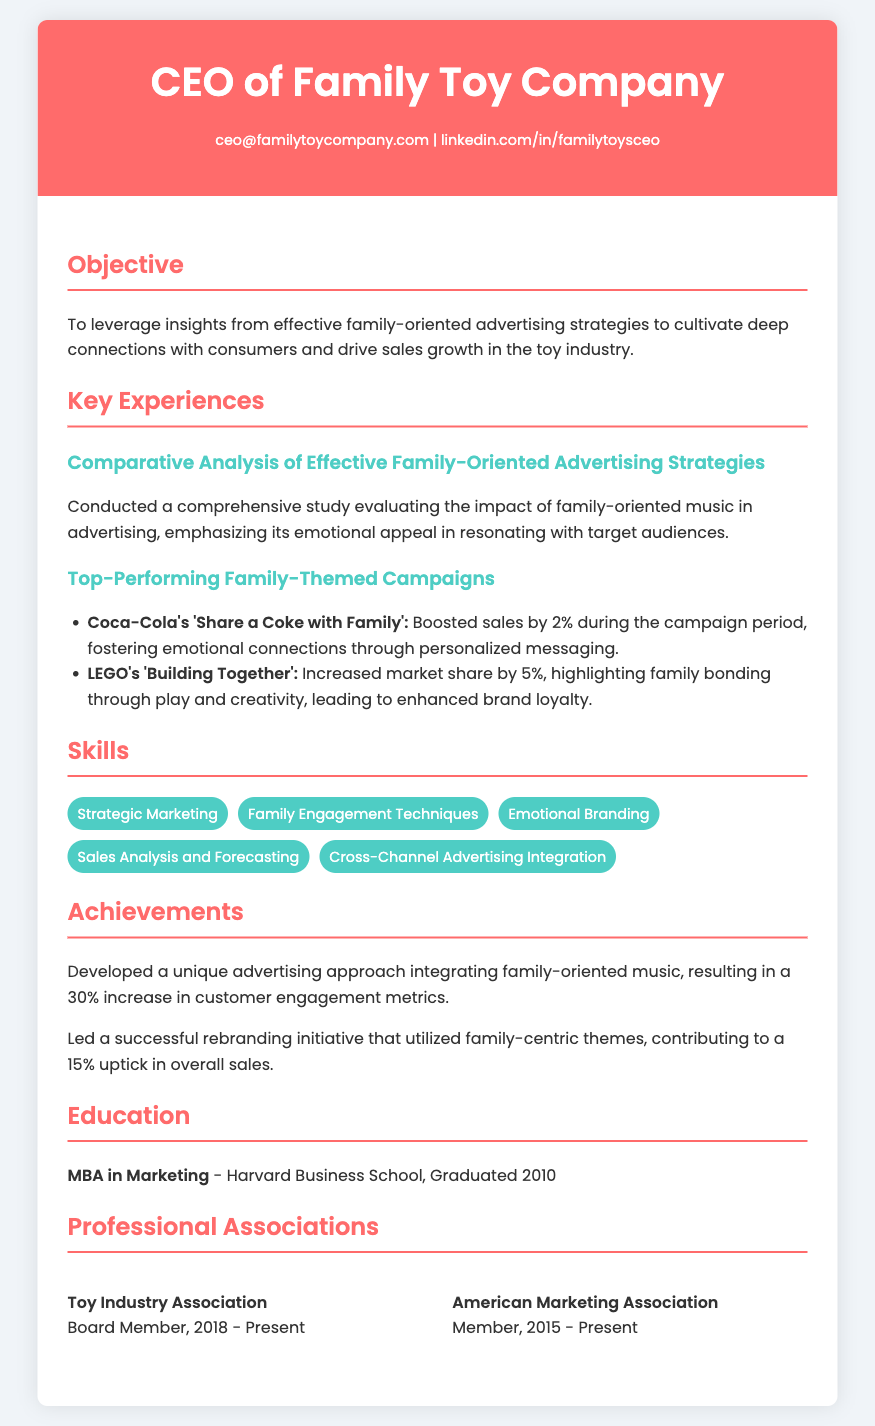What is the CEO's email address? The email address is located in the contact information section of the resume.
Answer: ceo@familytoycompany.com What was the increase in customer engagement metrics due to the advertising approach? This information is detailed in the achievements section, which highlights the outcome of the unique advertising approach.
Answer: 30% Which campaign boosted sales by 2%? The campaign is specified in the section discussing top-performing family-themed campaigns, indicating its effectiveness.
Answer: Coca-Cola's 'Share a Coke with Family' When did the CEO graduate from Harvard Business School? The graduation year is mentioned in the education section of the resume.
Answer: 2010 What is one of the skills listed on the resume? The skills section lists various skills relevant to the position.
Answer: Strategic Marketing What percentage increase in overall sales did the rebranding initiative contribute to? This figure is included in the achievements section, showcasing the impact of the rebranding initiative.
Answer: 15% What organization does the CEO serve as a Board Member? This information is located in the professional associations section of the resume.
Answer: Toy Industry Association What type of degree does the CEO hold? The education section specifies the degree attained by the CEO.
Answer: MBA in Marketing 